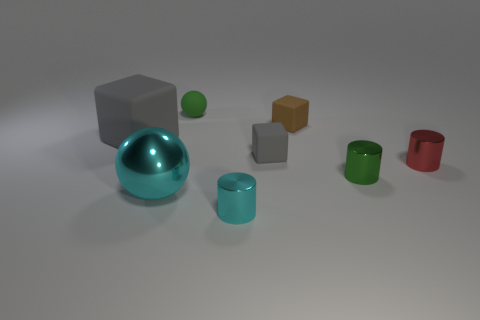Can you describe the colors of the objects in the image? Certainly! There's a variety of colors visible among the objects: a grey cube, a shiny turquoise sphere, a green sphere, an orange cube, a red cylinder, and two smaller objects, one teal and one green cylinder. 